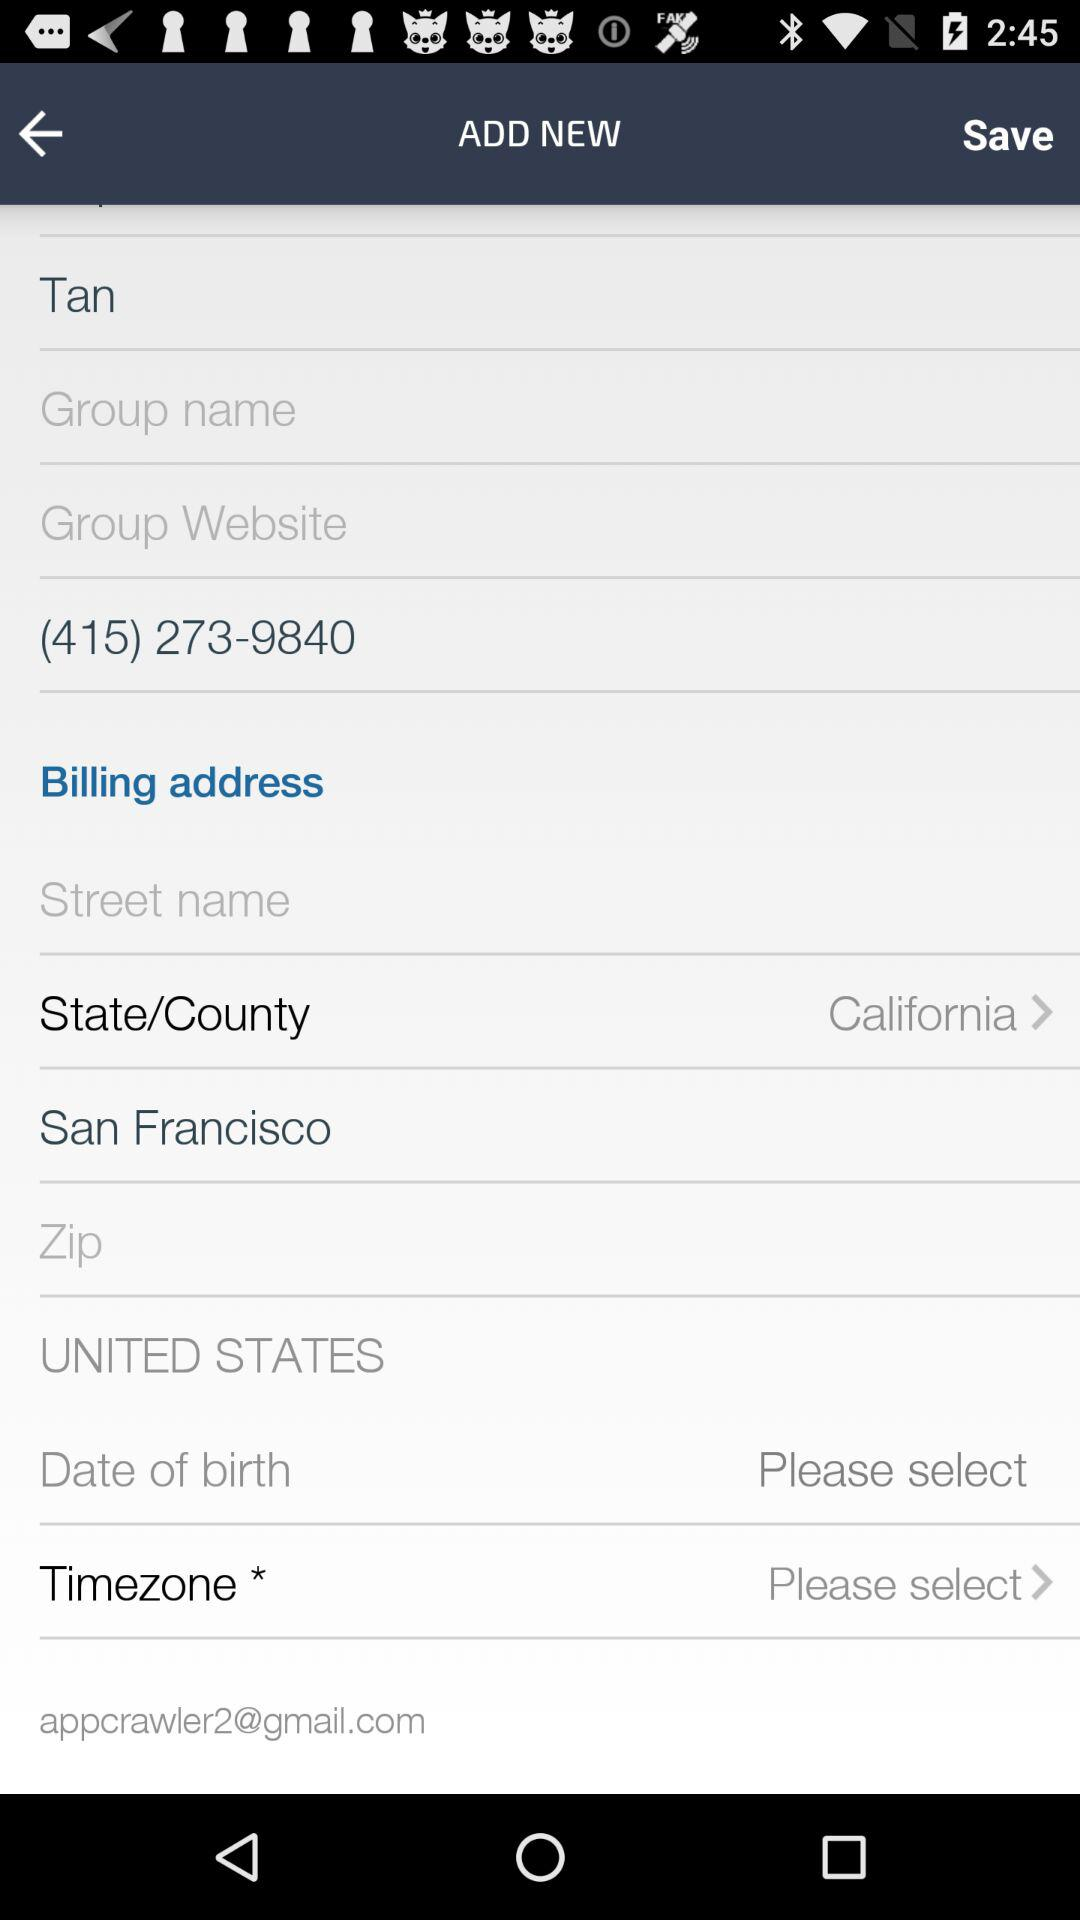How many text inputs are required in the billing address section?
Answer the question using a single word or phrase. 3 